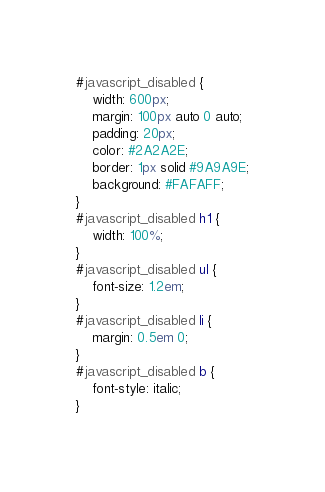Convert code to text. <code><loc_0><loc_0><loc_500><loc_500><_CSS_>#javascript_disabled {
    width: 600px;
    margin: 100px auto 0 auto;
    padding: 20px;
    color: #2A2A2E;
    border: 1px solid #9A9A9E;
    background: #FAFAFF;
}
#javascript_disabled h1 {
    width: 100%;
}
#javascript_disabled ul {
    font-size: 1.2em;
}
#javascript_disabled li {
    margin: 0.5em 0;
}
#javascript_disabled b {
    font-style: italic;
}
</code> 